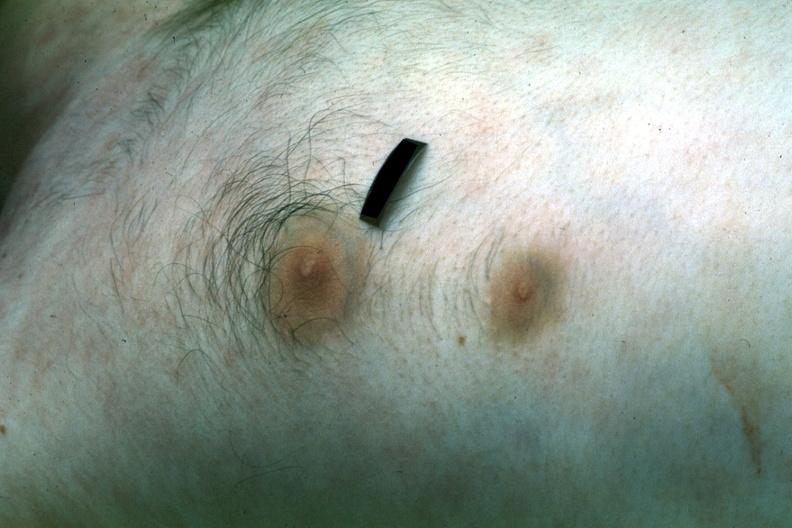what is present?
Answer the question using a single word or phrase. Nipple duplication 